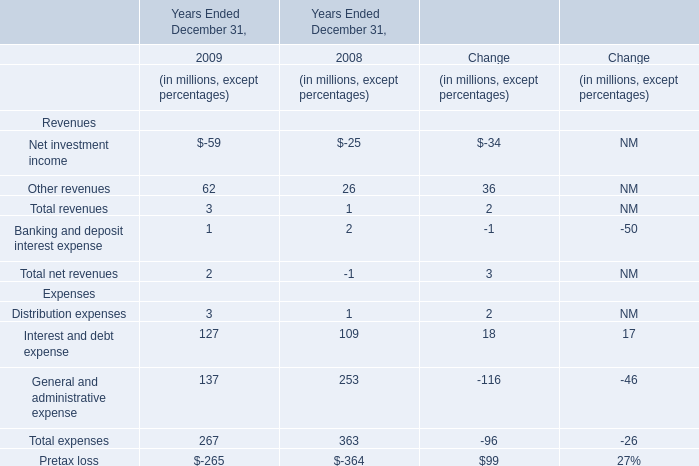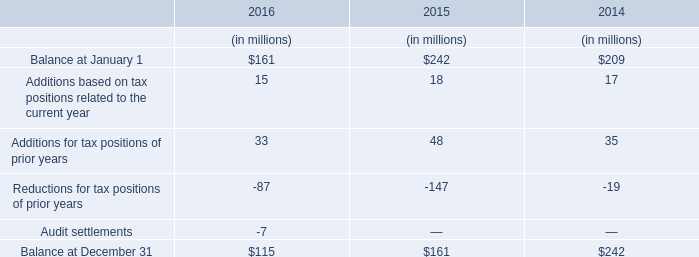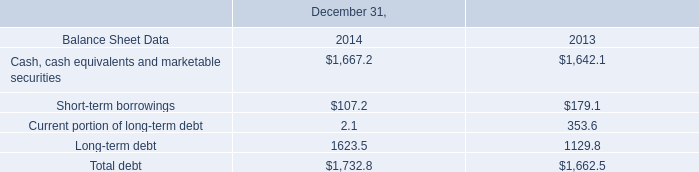What's the total amount of Net investment income, Other revenues, Distribution expenses and Interest and debt expense in 2009? (in million) 
Computations: (((-59 + 62) + 3) + 127)
Answer: 133.0. 